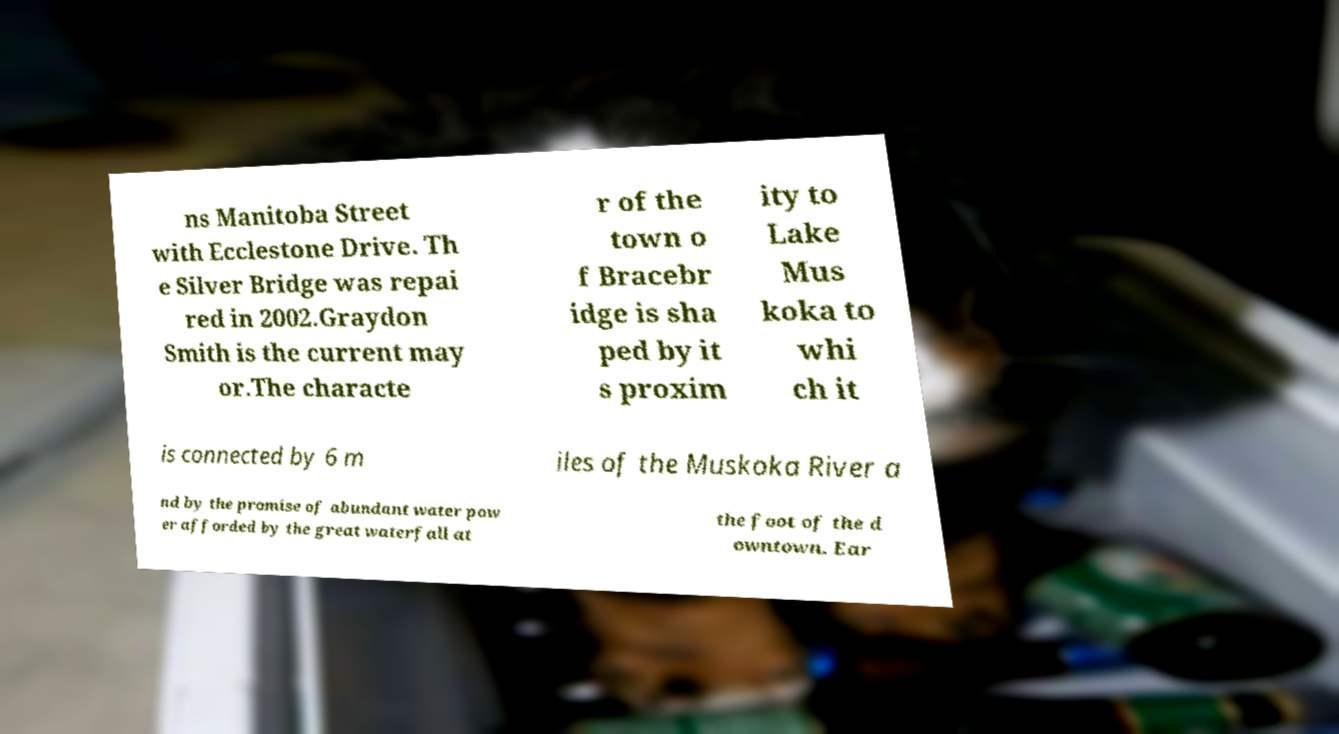Can you read and provide the text displayed in the image?This photo seems to have some interesting text. Can you extract and type it out for me? ns Manitoba Street with Ecclestone Drive. Th e Silver Bridge was repai red in 2002.Graydon Smith is the current may or.The characte r of the town o f Bracebr idge is sha ped by it s proxim ity to Lake Mus koka to whi ch it is connected by 6 m iles of the Muskoka River a nd by the promise of abundant water pow er afforded by the great waterfall at the foot of the d owntown. Ear 